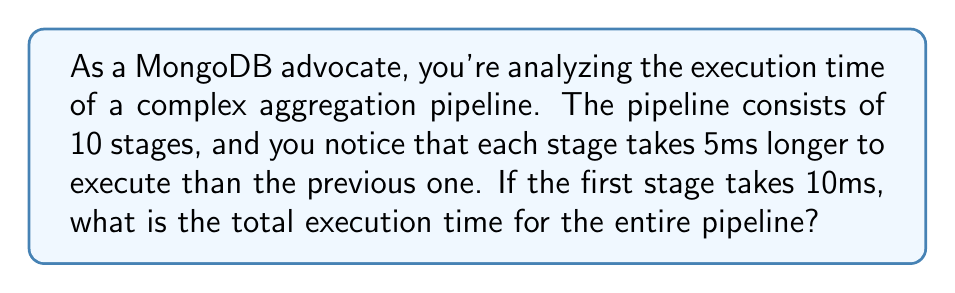Teach me how to tackle this problem. Let's approach this step-by-step using an arithmetic sequence:

1) We have an arithmetic sequence where:
   - First term, $a_1 = 10$ ms
   - Common difference, $d = 5$ ms
   - Number of terms, $n = 10$ (10 stages)

2) The last term of the sequence can be calculated using:
   $$a_n = a_1 + (n-1)d$$
   $$a_{10} = 10 + (10-1)5 = 10 + 45 = 55$$ ms

3) To find the total execution time, we need to sum all terms. For an arithmetic sequence, we can use the formula:
   $$S_n = \frac{n}{2}(a_1 + a_n)$$

   Where $S_n$ is the sum of $n$ terms, $a_1$ is the first term, and $a_n$ is the last term.

4) Substituting our values:
   $$S_{10} = \frac{10}{2}(10 + 55)$$
   $$S_{10} = 5(65)$$
   $$S_{10} = 325$$ ms

Therefore, the total execution time for the entire pipeline is 325 ms.
Answer: 325 ms 